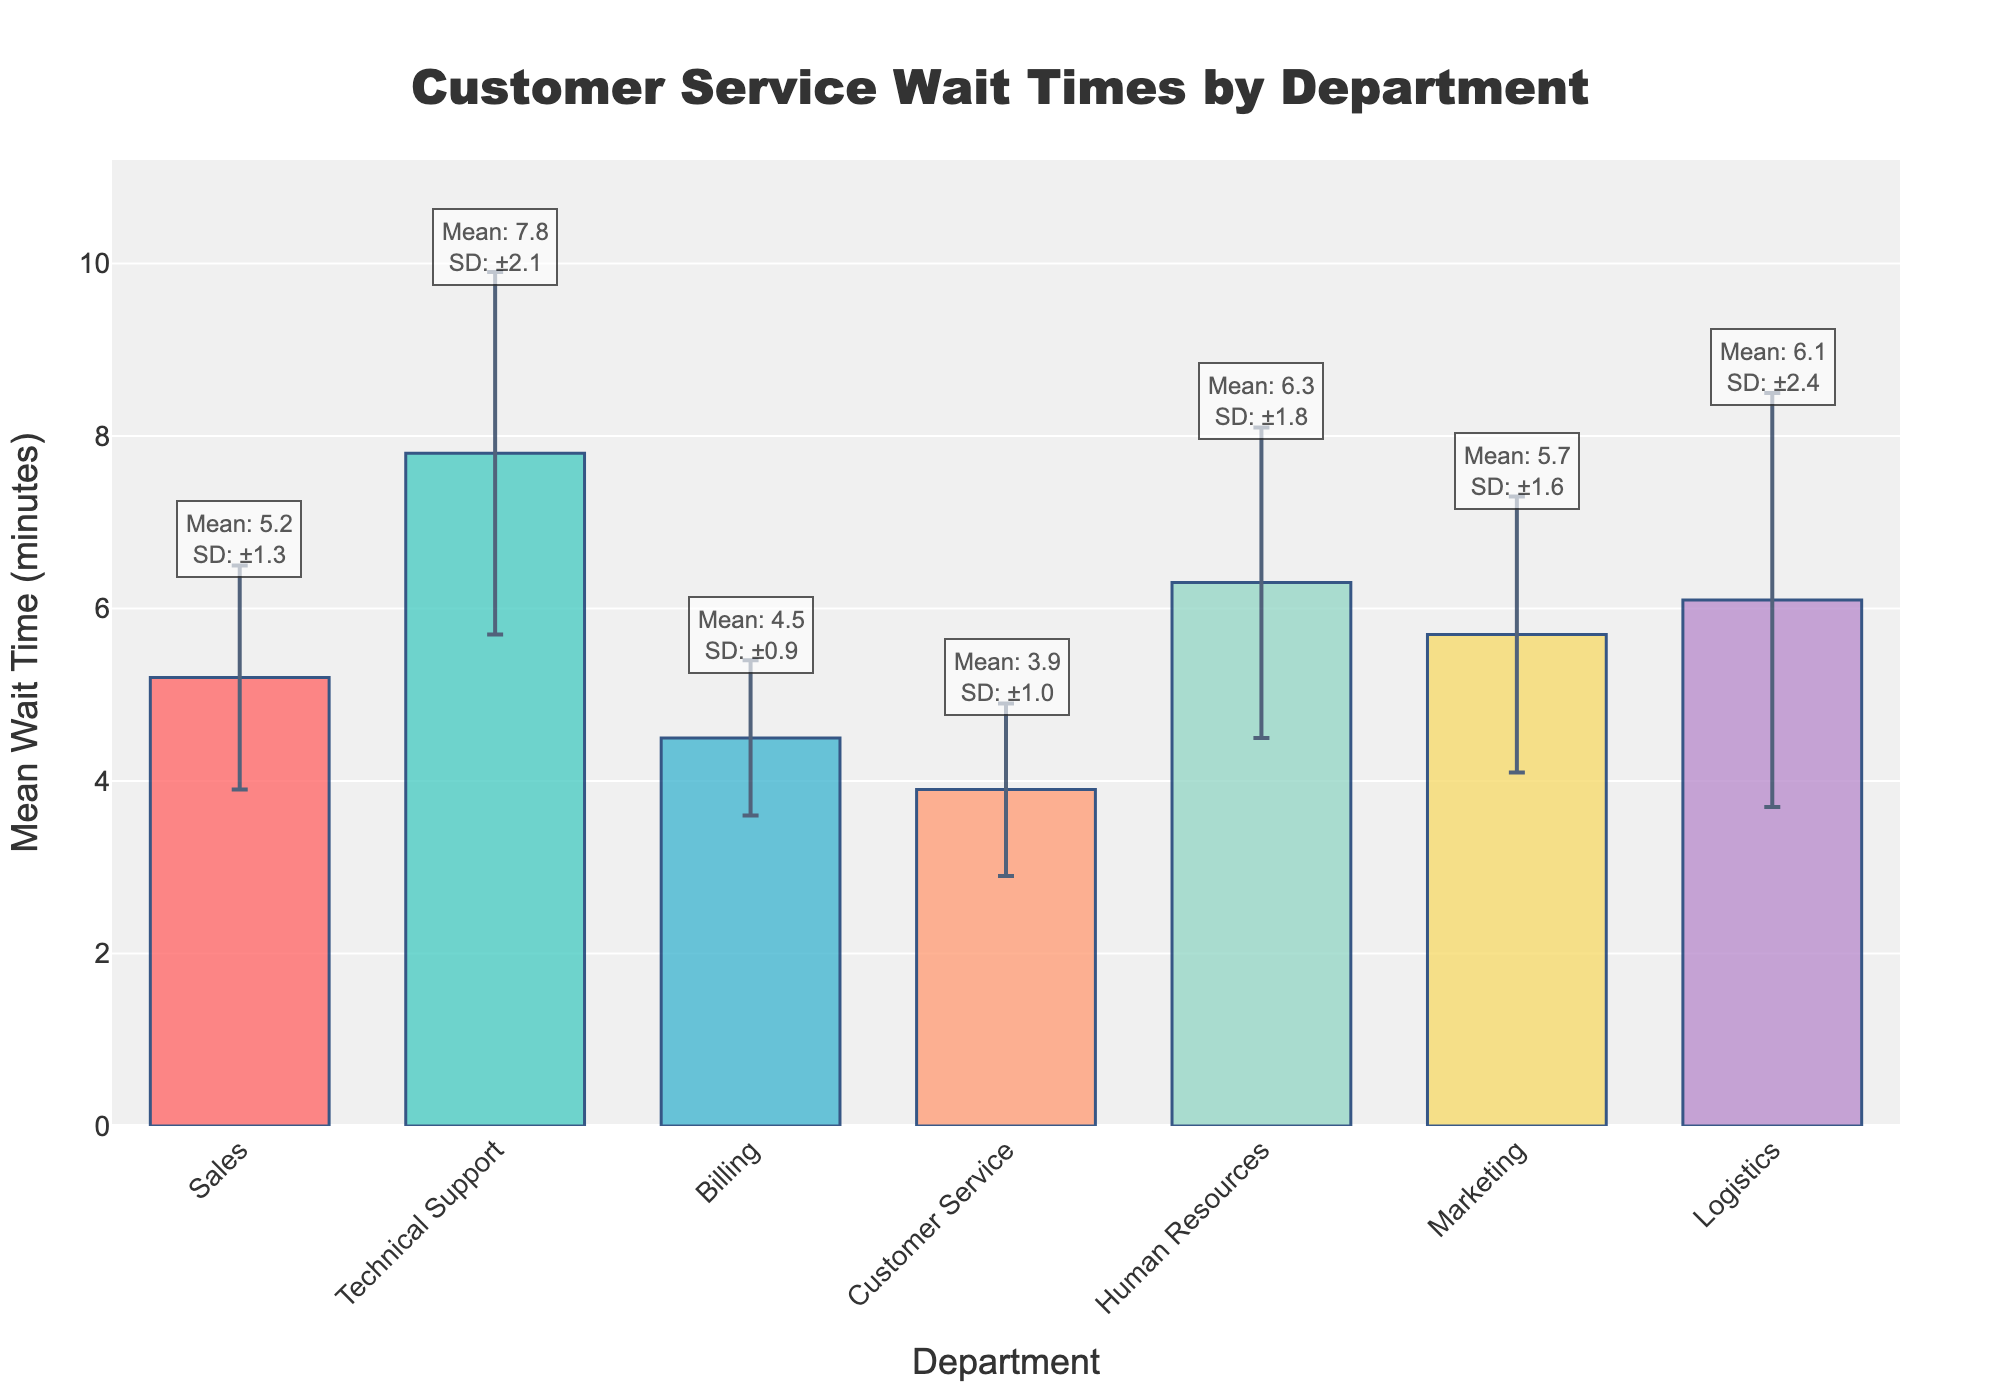what is the title of the figure? The title is located at the top center of the figure. It is written in a larger, bold font for visibility and summarizes the content of the chart.
Answer: "Customer Service Wait Times by Department" What is the range of the y-axis? The y-axis range is indicated by the scale marked along the vertical axis. It starts at 0 and goes up to slightly above the maximum mean wait time plus the highest standard deviation. In this case, it ranges from 0 to approximately 11.
Answer: 0 to 11 Which department has the shortest mean wait time? By looking at the height of the bars, the department with the shortest bar has the smallest mean wait time. In this figure, the Customer Service bar is the shortest.
Answer: Customer Service What is the mean wait time for Technical Support, and what is its variability? Locate the bar for Technical Support and read the mean wait time from the top of the bar. The variability is represented by the error bar extending upwards and downwards from the bar's top.
Answer: Mean: 7.8, Variability: ±2.1 Which two departments have the closest mean wait times? Compare the heights of the bars visually to identify the ones with a similar height. Billing and Customer Service have the closest mean wait times.
Answer: Billing and Customer Service Which department has the highest variability in wait times? The highest variability is indicated by the longest error bar. In this figure, the Logistics department has the longest error bar.
Answer: Logistics What is the total sum of the mean wait times for all departments? Each department's mean wait time needs to be summed up: Sales (5.2) + Technical Support (7.8) + Billing (4.5) + Customer Service (3.9) + Human Resources (6.3) + Marketing (5.7) + Logistics (6.1). Adding these values gives a sum of 39.5.
Answer: 39.5 How much longer is the mean wait time for Technical Support compared to Billing? Subtract the mean wait time of Billing from Technical Support to find the difference: 7.8 (Technical Support) - 4.5 (Billing) = 3.3 minutes.
Answer: 3.3 minutes What is the average standard deviation of all departments? To find the average standard deviation, sum the standard deviations and divide by the number of departments: (1.3 + 2.1 + 0.9 + 1.0 + 1.8 + 1.6 + 2.4) / 7 = 11.1 / 7 ≈ 1.59 minutes.
Answer: 1.59 minutes Which department's mean wait time is closest to the overall average mean wait time of all departments? First compute the overall average mean wait time: (5.2 + 7.8 + 4.5 + 3.9 + 6.3 + 5.7 + 6.1) / 7 ≈ 5.64. Next, find the department closest to this value. Marketing has a mean wait time of 5.7, which is closest to 5.64.
Answer: Marketing 